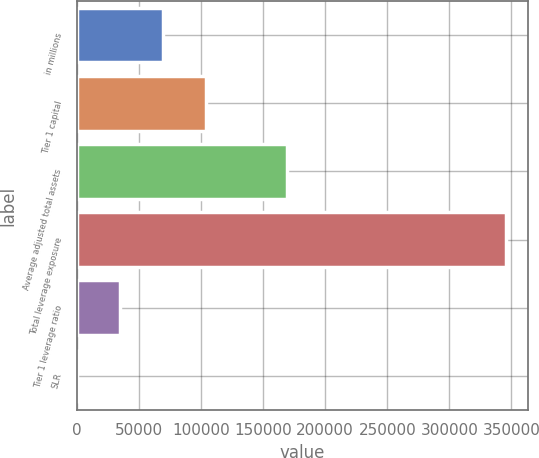Convert chart to OTSL. <chart><loc_0><loc_0><loc_500><loc_500><bar_chart><fcel>in millions<fcel>Tier 1 capital<fcel>Average adjusted total assets<fcel>Total leverage exposure<fcel>Tier 1 leverage ratio<fcel>SLR<nl><fcel>69152.6<fcel>103725<fcel>168842<fcel>345734<fcel>34580<fcel>7.3<nl></chart> 